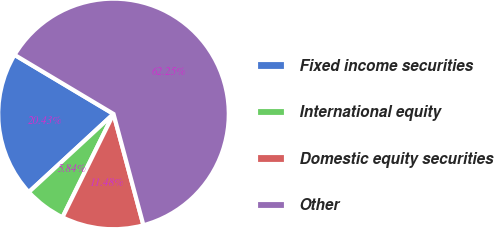Convert chart to OTSL. <chart><loc_0><loc_0><loc_500><loc_500><pie_chart><fcel>Fixed income securities<fcel>International equity<fcel>Domestic equity securities<fcel>Other<nl><fcel>20.43%<fcel>5.84%<fcel>11.48%<fcel>62.26%<nl></chart> 